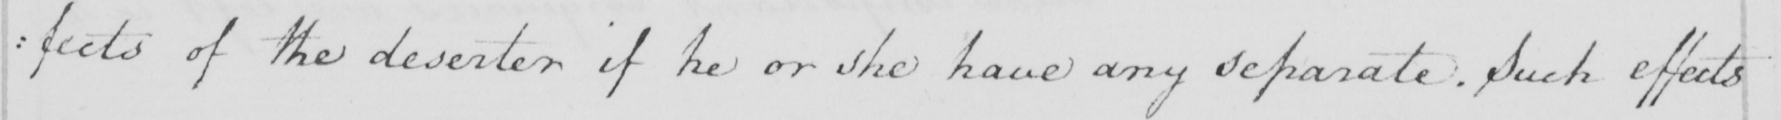Please transcribe the handwritten text in this image. : fects of the deserter if he or she have any separate . Such effects 